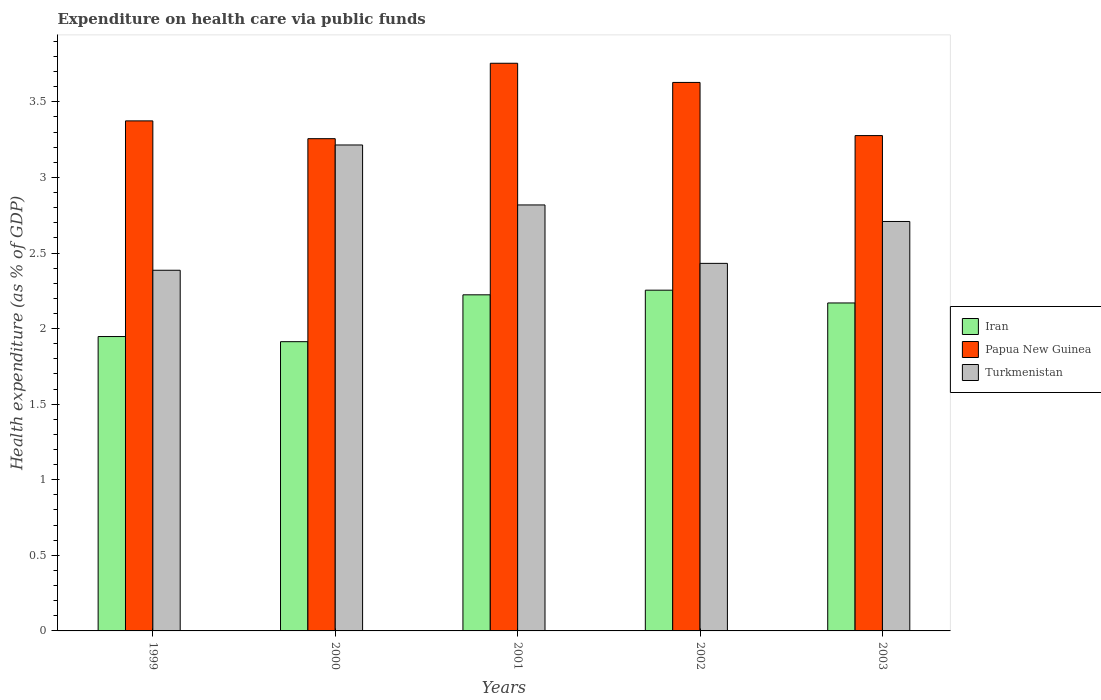How many groups of bars are there?
Offer a terse response. 5. How many bars are there on the 1st tick from the left?
Your answer should be very brief. 3. What is the label of the 3rd group of bars from the left?
Make the answer very short. 2001. In how many cases, is the number of bars for a given year not equal to the number of legend labels?
Offer a terse response. 0. What is the expenditure made on health care in Turkmenistan in 2000?
Your answer should be compact. 3.21. Across all years, what is the maximum expenditure made on health care in Papua New Guinea?
Offer a terse response. 3.76. Across all years, what is the minimum expenditure made on health care in Papua New Guinea?
Give a very brief answer. 3.26. In which year was the expenditure made on health care in Papua New Guinea minimum?
Give a very brief answer. 2000. What is the total expenditure made on health care in Turkmenistan in the graph?
Your response must be concise. 13.56. What is the difference between the expenditure made on health care in Papua New Guinea in 2001 and that in 2003?
Give a very brief answer. 0.48. What is the difference between the expenditure made on health care in Turkmenistan in 2002 and the expenditure made on health care in Iran in 1999?
Give a very brief answer. 0.48. What is the average expenditure made on health care in Turkmenistan per year?
Your response must be concise. 2.71. In the year 2003, what is the difference between the expenditure made on health care in Turkmenistan and expenditure made on health care in Papua New Guinea?
Offer a very short reply. -0.57. What is the ratio of the expenditure made on health care in Papua New Guinea in 1999 to that in 2000?
Provide a short and direct response. 1.04. Is the expenditure made on health care in Iran in 1999 less than that in 2003?
Ensure brevity in your answer.  Yes. Is the difference between the expenditure made on health care in Turkmenistan in 2001 and 2003 greater than the difference between the expenditure made on health care in Papua New Guinea in 2001 and 2003?
Ensure brevity in your answer.  No. What is the difference between the highest and the second highest expenditure made on health care in Iran?
Provide a succinct answer. 0.03. What is the difference between the highest and the lowest expenditure made on health care in Papua New Guinea?
Offer a very short reply. 0.5. In how many years, is the expenditure made on health care in Iran greater than the average expenditure made on health care in Iran taken over all years?
Your answer should be very brief. 3. Is the sum of the expenditure made on health care in Papua New Guinea in 2000 and 2001 greater than the maximum expenditure made on health care in Turkmenistan across all years?
Your response must be concise. Yes. What does the 3rd bar from the left in 2002 represents?
Keep it short and to the point. Turkmenistan. What does the 2nd bar from the right in 2000 represents?
Provide a short and direct response. Papua New Guinea. Are all the bars in the graph horizontal?
Provide a short and direct response. No. How many years are there in the graph?
Provide a short and direct response. 5. What is the difference between two consecutive major ticks on the Y-axis?
Make the answer very short. 0.5. Are the values on the major ticks of Y-axis written in scientific E-notation?
Give a very brief answer. No. Does the graph contain any zero values?
Your answer should be very brief. No. How are the legend labels stacked?
Provide a short and direct response. Vertical. What is the title of the graph?
Ensure brevity in your answer.  Expenditure on health care via public funds. Does "Upper middle income" appear as one of the legend labels in the graph?
Your response must be concise. No. What is the label or title of the Y-axis?
Keep it short and to the point. Health expenditure (as % of GDP). What is the Health expenditure (as % of GDP) in Iran in 1999?
Provide a short and direct response. 1.95. What is the Health expenditure (as % of GDP) in Papua New Guinea in 1999?
Provide a succinct answer. 3.37. What is the Health expenditure (as % of GDP) of Turkmenistan in 1999?
Your response must be concise. 2.39. What is the Health expenditure (as % of GDP) in Iran in 2000?
Give a very brief answer. 1.91. What is the Health expenditure (as % of GDP) of Papua New Guinea in 2000?
Provide a succinct answer. 3.26. What is the Health expenditure (as % of GDP) of Turkmenistan in 2000?
Offer a terse response. 3.21. What is the Health expenditure (as % of GDP) in Iran in 2001?
Make the answer very short. 2.22. What is the Health expenditure (as % of GDP) of Papua New Guinea in 2001?
Give a very brief answer. 3.76. What is the Health expenditure (as % of GDP) of Turkmenistan in 2001?
Offer a terse response. 2.82. What is the Health expenditure (as % of GDP) in Iran in 2002?
Keep it short and to the point. 2.25. What is the Health expenditure (as % of GDP) in Papua New Guinea in 2002?
Provide a short and direct response. 3.63. What is the Health expenditure (as % of GDP) in Turkmenistan in 2002?
Provide a short and direct response. 2.43. What is the Health expenditure (as % of GDP) of Iran in 2003?
Your answer should be compact. 2.17. What is the Health expenditure (as % of GDP) in Papua New Guinea in 2003?
Make the answer very short. 3.28. What is the Health expenditure (as % of GDP) of Turkmenistan in 2003?
Your answer should be very brief. 2.71. Across all years, what is the maximum Health expenditure (as % of GDP) in Iran?
Your answer should be compact. 2.25. Across all years, what is the maximum Health expenditure (as % of GDP) of Papua New Guinea?
Ensure brevity in your answer.  3.76. Across all years, what is the maximum Health expenditure (as % of GDP) in Turkmenistan?
Your answer should be very brief. 3.21. Across all years, what is the minimum Health expenditure (as % of GDP) of Iran?
Provide a short and direct response. 1.91. Across all years, what is the minimum Health expenditure (as % of GDP) in Papua New Guinea?
Your response must be concise. 3.26. Across all years, what is the minimum Health expenditure (as % of GDP) in Turkmenistan?
Your response must be concise. 2.39. What is the total Health expenditure (as % of GDP) of Iran in the graph?
Your answer should be compact. 10.51. What is the total Health expenditure (as % of GDP) in Papua New Guinea in the graph?
Keep it short and to the point. 17.29. What is the total Health expenditure (as % of GDP) in Turkmenistan in the graph?
Your answer should be very brief. 13.56. What is the difference between the Health expenditure (as % of GDP) of Iran in 1999 and that in 2000?
Offer a terse response. 0.03. What is the difference between the Health expenditure (as % of GDP) in Papua New Guinea in 1999 and that in 2000?
Your answer should be compact. 0.12. What is the difference between the Health expenditure (as % of GDP) in Turkmenistan in 1999 and that in 2000?
Give a very brief answer. -0.83. What is the difference between the Health expenditure (as % of GDP) of Iran in 1999 and that in 2001?
Your answer should be compact. -0.28. What is the difference between the Health expenditure (as % of GDP) in Papua New Guinea in 1999 and that in 2001?
Provide a succinct answer. -0.38. What is the difference between the Health expenditure (as % of GDP) in Turkmenistan in 1999 and that in 2001?
Ensure brevity in your answer.  -0.43. What is the difference between the Health expenditure (as % of GDP) of Iran in 1999 and that in 2002?
Your response must be concise. -0.31. What is the difference between the Health expenditure (as % of GDP) of Papua New Guinea in 1999 and that in 2002?
Your answer should be compact. -0.25. What is the difference between the Health expenditure (as % of GDP) in Turkmenistan in 1999 and that in 2002?
Your answer should be very brief. -0.05. What is the difference between the Health expenditure (as % of GDP) of Iran in 1999 and that in 2003?
Keep it short and to the point. -0.22. What is the difference between the Health expenditure (as % of GDP) of Papua New Guinea in 1999 and that in 2003?
Offer a terse response. 0.1. What is the difference between the Health expenditure (as % of GDP) of Turkmenistan in 1999 and that in 2003?
Ensure brevity in your answer.  -0.32. What is the difference between the Health expenditure (as % of GDP) in Iran in 2000 and that in 2001?
Make the answer very short. -0.31. What is the difference between the Health expenditure (as % of GDP) in Papua New Guinea in 2000 and that in 2001?
Your answer should be very brief. -0.5. What is the difference between the Health expenditure (as % of GDP) of Turkmenistan in 2000 and that in 2001?
Offer a terse response. 0.4. What is the difference between the Health expenditure (as % of GDP) of Iran in 2000 and that in 2002?
Your answer should be compact. -0.34. What is the difference between the Health expenditure (as % of GDP) of Papua New Guinea in 2000 and that in 2002?
Your answer should be compact. -0.37. What is the difference between the Health expenditure (as % of GDP) in Turkmenistan in 2000 and that in 2002?
Provide a short and direct response. 0.78. What is the difference between the Health expenditure (as % of GDP) in Iran in 2000 and that in 2003?
Offer a very short reply. -0.26. What is the difference between the Health expenditure (as % of GDP) in Papua New Guinea in 2000 and that in 2003?
Provide a succinct answer. -0.02. What is the difference between the Health expenditure (as % of GDP) of Turkmenistan in 2000 and that in 2003?
Give a very brief answer. 0.51. What is the difference between the Health expenditure (as % of GDP) in Iran in 2001 and that in 2002?
Ensure brevity in your answer.  -0.03. What is the difference between the Health expenditure (as % of GDP) of Papua New Guinea in 2001 and that in 2002?
Give a very brief answer. 0.13. What is the difference between the Health expenditure (as % of GDP) of Turkmenistan in 2001 and that in 2002?
Ensure brevity in your answer.  0.39. What is the difference between the Health expenditure (as % of GDP) in Iran in 2001 and that in 2003?
Your answer should be compact. 0.05. What is the difference between the Health expenditure (as % of GDP) of Papua New Guinea in 2001 and that in 2003?
Provide a succinct answer. 0.48. What is the difference between the Health expenditure (as % of GDP) in Turkmenistan in 2001 and that in 2003?
Your answer should be very brief. 0.11. What is the difference between the Health expenditure (as % of GDP) in Iran in 2002 and that in 2003?
Give a very brief answer. 0.08. What is the difference between the Health expenditure (as % of GDP) in Papua New Guinea in 2002 and that in 2003?
Offer a very short reply. 0.35. What is the difference between the Health expenditure (as % of GDP) in Turkmenistan in 2002 and that in 2003?
Make the answer very short. -0.28. What is the difference between the Health expenditure (as % of GDP) of Iran in 1999 and the Health expenditure (as % of GDP) of Papua New Guinea in 2000?
Your answer should be compact. -1.31. What is the difference between the Health expenditure (as % of GDP) of Iran in 1999 and the Health expenditure (as % of GDP) of Turkmenistan in 2000?
Offer a very short reply. -1.27. What is the difference between the Health expenditure (as % of GDP) of Papua New Guinea in 1999 and the Health expenditure (as % of GDP) of Turkmenistan in 2000?
Your answer should be compact. 0.16. What is the difference between the Health expenditure (as % of GDP) of Iran in 1999 and the Health expenditure (as % of GDP) of Papua New Guinea in 2001?
Your answer should be very brief. -1.81. What is the difference between the Health expenditure (as % of GDP) of Iran in 1999 and the Health expenditure (as % of GDP) of Turkmenistan in 2001?
Make the answer very short. -0.87. What is the difference between the Health expenditure (as % of GDP) of Papua New Guinea in 1999 and the Health expenditure (as % of GDP) of Turkmenistan in 2001?
Make the answer very short. 0.56. What is the difference between the Health expenditure (as % of GDP) in Iran in 1999 and the Health expenditure (as % of GDP) in Papua New Guinea in 2002?
Offer a terse response. -1.68. What is the difference between the Health expenditure (as % of GDP) of Iran in 1999 and the Health expenditure (as % of GDP) of Turkmenistan in 2002?
Provide a short and direct response. -0.48. What is the difference between the Health expenditure (as % of GDP) of Papua New Guinea in 1999 and the Health expenditure (as % of GDP) of Turkmenistan in 2002?
Offer a very short reply. 0.94. What is the difference between the Health expenditure (as % of GDP) of Iran in 1999 and the Health expenditure (as % of GDP) of Papua New Guinea in 2003?
Your response must be concise. -1.33. What is the difference between the Health expenditure (as % of GDP) in Iran in 1999 and the Health expenditure (as % of GDP) in Turkmenistan in 2003?
Your answer should be very brief. -0.76. What is the difference between the Health expenditure (as % of GDP) in Papua New Guinea in 1999 and the Health expenditure (as % of GDP) in Turkmenistan in 2003?
Your answer should be compact. 0.67. What is the difference between the Health expenditure (as % of GDP) in Iran in 2000 and the Health expenditure (as % of GDP) in Papua New Guinea in 2001?
Offer a very short reply. -1.84. What is the difference between the Health expenditure (as % of GDP) of Iran in 2000 and the Health expenditure (as % of GDP) of Turkmenistan in 2001?
Offer a terse response. -0.9. What is the difference between the Health expenditure (as % of GDP) in Papua New Guinea in 2000 and the Health expenditure (as % of GDP) in Turkmenistan in 2001?
Ensure brevity in your answer.  0.44. What is the difference between the Health expenditure (as % of GDP) of Iran in 2000 and the Health expenditure (as % of GDP) of Papua New Guinea in 2002?
Give a very brief answer. -1.72. What is the difference between the Health expenditure (as % of GDP) in Iran in 2000 and the Health expenditure (as % of GDP) in Turkmenistan in 2002?
Provide a succinct answer. -0.52. What is the difference between the Health expenditure (as % of GDP) of Papua New Guinea in 2000 and the Health expenditure (as % of GDP) of Turkmenistan in 2002?
Your answer should be very brief. 0.82. What is the difference between the Health expenditure (as % of GDP) of Iran in 2000 and the Health expenditure (as % of GDP) of Papua New Guinea in 2003?
Give a very brief answer. -1.36. What is the difference between the Health expenditure (as % of GDP) of Iran in 2000 and the Health expenditure (as % of GDP) of Turkmenistan in 2003?
Make the answer very short. -0.8. What is the difference between the Health expenditure (as % of GDP) of Papua New Guinea in 2000 and the Health expenditure (as % of GDP) of Turkmenistan in 2003?
Offer a very short reply. 0.55. What is the difference between the Health expenditure (as % of GDP) in Iran in 2001 and the Health expenditure (as % of GDP) in Papua New Guinea in 2002?
Your answer should be very brief. -1.4. What is the difference between the Health expenditure (as % of GDP) in Iran in 2001 and the Health expenditure (as % of GDP) in Turkmenistan in 2002?
Offer a terse response. -0.21. What is the difference between the Health expenditure (as % of GDP) in Papua New Guinea in 2001 and the Health expenditure (as % of GDP) in Turkmenistan in 2002?
Keep it short and to the point. 1.32. What is the difference between the Health expenditure (as % of GDP) in Iran in 2001 and the Health expenditure (as % of GDP) in Papua New Guinea in 2003?
Your response must be concise. -1.05. What is the difference between the Health expenditure (as % of GDP) in Iran in 2001 and the Health expenditure (as % of GDP) in Turkmenistan in 2003?
Offer a terse response. -0.49. What is the difference between the Health expenditure (as % of GDP) in Papua New Guinea in 2001 and the Health expenditure (as % of GDP) in Turkmenistan in 2003?
Ensure brevity in your answer.  1.05. What is the difference between the Health expenditure (as % of GDP) in Iran in 2002 and the Health expenditure (as % of GDP) in Papua New Guinea in 2003?
Make the answer very short. -1.02. What is the difference between the Health expenditure (as % of GDP) in Iran in 2002 and the Health expenditure (as % of GDP) in Turkmenistan in 2003?
Make the answer very short. -0.45. What is the difference between the Health expenditure (as % of GDP) in Papua New Guinea in 2002 and the Health expenditure (as % of GDP) in Turkmenistan in 2003?
Provide a succinct answer. 0.92. What is the average Health expenditure (as % of GDP) in Iran per year?
Give a very brief answer. 2.1. What is the average Health expenditure (as % of GDP) in Papua New Guinea per year?
Offer a terse response. 3.46. What is the average Health expenditure (as % of GDP) in Turkmenistan per year?
Ensure brevity in your answer.  2.71. In the year 1999, what is the difference between the Health expenditure (as % of GDP) in Iran and Health expenditure (as % of GDP) in Papua New Guinea?
Give a very brief answer. -1.43. In the year 1999, what is the difference between the Health expenditure (as % of GDP) in Iran and Health expenditure (as % of GDP) in Turkmenistan?
Your answer should be very brief. -0.44. In the year 2000, what is the difference between the Health expenditure (as % of GDP) of Iran and Health expenditure (as % of GDP) of Papua New Guinea?
Keep it short and to the point. -1.34. In the year 2000, what is the difference between the Health expenditure (as % of GDP) in Iran and Health expenditure (as % of GDP) in Turkmenistan?
Provide a succinct answer. -1.3. In the year 2000, what is the difference between the Health expenditure (as % of GDP) of Papua New Guinea and Health expenditure (as % of GDP) of Turkmenistan?
Provide a short and direct response. 0.04. In the year 2001, what is the difference between the Health expenditure (as % of GDP) of Iran and Health expenditure (as % of GDP) of Papua New Guinea?
Your response must be concise. -1.53. In the year 2001, what is the difference between the Health expenditure (as % of GDP) of Iran and Health expenditure (as % of GDP) of Turkmenistan?
Give a very brief answer. -0.59. In the year 2001, what is the difference between the Health expenditure (as % of GDP) in Papua New Guinea and Health expenditure (as % of GDP) in Turkmenistan?
Provide a succinct answer. 0.94. In the year 2002, what is the difference between the Health expenditure (as % of GDP) in Iran and Health expenditure (as % of GDP) in Papua New Guinea?
Offer a terse response. -1.37. In the year 2002, what is the difference between the Health expenditure (as % of GDP) of Iran and Health expenditure (as % of GDP) of Turkmenistan?
Offer a very short reply. -0.18. In the year 2002, what is the difference between the Health expenditure (as % of GDP) of Papua New Guinea and Health expenditure (as % of GDP) of Turkmenistan?
Your answer should be very brief. 1.2. In the year 2003, what is the difference between the Health expenditure (as % of GDP) of Iran and Health expenditure (as % of GDP) of Papua New Guinea?
Provide a succinct answer. -1.11. In the year 2003, what is the difference between the Health expenditure (as % of GDP) in Iran and Health expenditure (as % of GDP) in Turkmenistan?
Offer a terse response. -0.54. In the year 2003, what is the difference between the Health expenditure (as % of GDP) in Papua New Guinea and Health expenditure (as % of GDP) in Turkmenistan?
Make the answer very short. 0.57. What is the ratio of the Health expenditure (as % of GDP) of Iran in 1999 to that in 2000?
Make the answer very short. 1.02. What is the ratio of the Health expenditure (as % of GDP) of Papua New Guinea in 1999 to that in 2000?
Offer a terse response. 1.04. What is the ratio of the Health expenditure (as % of GDP) of Turkmenistan in 1999 to that in 2000?
Give a very brief answer. 0.74. What is the ratio of the Health expenditure (as % of GDP) of Iran in 1999 to that in 2001?
Keep it short and to the point. 0.88. What is the ratio of the Health expenditure (as % of GDP) in Papua New Guinea in 1999 to that in 2001?
Provide a short and direct response. 0.9. What is the ratio of the Health expenditure (as % of GDP) of Turkmenistan in 1999 to that in 2001?
Your answer should be compact. 0.85. What is the ratio of the Health expenditure (as % of GDP) in Iran in 1999 to that in 2002?
Give a very brief answer. 0.86. What is the ratio of the Health expenditure (as % of GDP) of Papua New Guinea in 1999 to that in 2002?
Provide a succinct answer. 0.93. What is the ratio of the Health expenditure (as % of GDP) of Turkmenistan in 1999 to that in 2002?
Offer a terse response. 0.98. What is the ratio of the Health expenditure (as % of GDP) of Iran in 1999 to that in 2003?
Provide a short and direct response. 0.9. What is the ratio of the Health expenditure (as % of GDP) in Papua New Guinea in 1999 to that in 2003?
Offer a very short reply. 1.03. What is the ratio of the Health expenditure (as % of GDP) in Turkmenistan in 1999 to that in 2003?
Your answer should be very brief. 0.88. What is the ratio of the Health expenditure (as % of GDP) in Iran in 2000 to that in 2001?
Make the answer very short. 0.86. What is the ratio of the Health expenditure (as % of GDP) of Papua New Guinea in 2000 to that in 2001?
Your answer should be very brief. 0.87. What is the ratio of the Health expenditure (as % of GDP) of Turkmenistan in 2000 to that in 2001?
Give a very brief answer. 1.14. What is the ratio of the Health expenditure (as % of GDP) in Iran in 2000 to that in 2002?
Ensure brevity in your answer.  0.85. What is the ratio of the Health expenditure (as % of GDP) of Papua New Guinea in 2000 to that in 2002?
Your response must be concise. 0.9. What is the ratio of the Health expenditure (as % of GDP) in Turkmenistan in 2000 to that in 2002?
Your answer should be compact. 1.32. What is the ratio of the Health expenditure (as % of GDP) in Iran in 2000 to that in 2003?
Provide a short and direct response. 0.88. What is the ratio of the Health expenditure (as % of GDP) of Turkmenistan in 2000 to that in 2003?
Your answer should be compact. 1.19. What is the ratio of the Health expenditure (as % of GDP) in Iran in 2001 to that in 2002?
Your response must be concise. 0.99. What is the ratio of the Health expenditure (as % of GDP) in Papua New Guinea in 2001 to that in 2002?
Your answer should be compact. 1.03. What is the ratio of the Health expenditure (as % of GDP) in Turkmenistan in 2001 to that in 2002?
Your response must be concise. 1.16. What is the ratio of the Health expenditure (as % of GDP) in Iran in 2001 to that in 2003?
Ensure brevity in your answer.  1.02. What is the ratio of the Health expenditure (as % of GDP) of Papua New Guinea in 2001 to that in 2003?
Ensure brevity in your answer.  1.15. What is the ratio of the Health expenditure (as % of GDP) of Turkmenistan in 2001 to that in 2003?
Your answer should be compact. 1.04. What is the ratio of the Health expenditure (as % of GDP) of Iran in 2002 to that in 2003?
Ensure brevity in your answer.  1.04. What is the ratio of the Health expenditure (as % of GDP) in Papua New Guinea in 2002 to that in 2003?
Provide a short and direct response. 1.11. What is the ratio of the Health expenditure (as % of GDP) in Turkmenistan in 2002 to that in 2003?
Give a very brief answer. 0.9. What is the difference between the highest and the second highest Health expenditure (as % of GDP) of Iran?
Provide a short and direct response. 0.03. What is the difference between the highest and the second highest Health expenditure (as % of GDP) of Papua New Guinea?
Offer a very short reply. 0.13. What is the difference between the highest and the second highest Health expenditure (as % of GDP) of Turkmenistan?
Keep it short and to the point. 0.4. What is the difference between the highest and the lowest Health expenditure (as % of GDP) of Iran?
Provide a short and direct response. 0.34. What is the difference between the highest and the lowest Health expenditure (as % of GDP) in Papua New Guinea?
Make the answer very short. 0.5. What is the difference between the highest and the lowest Health expenditure (as % of GDP) in Turkmenistan?
Provide a succinct answer. 0.83. 